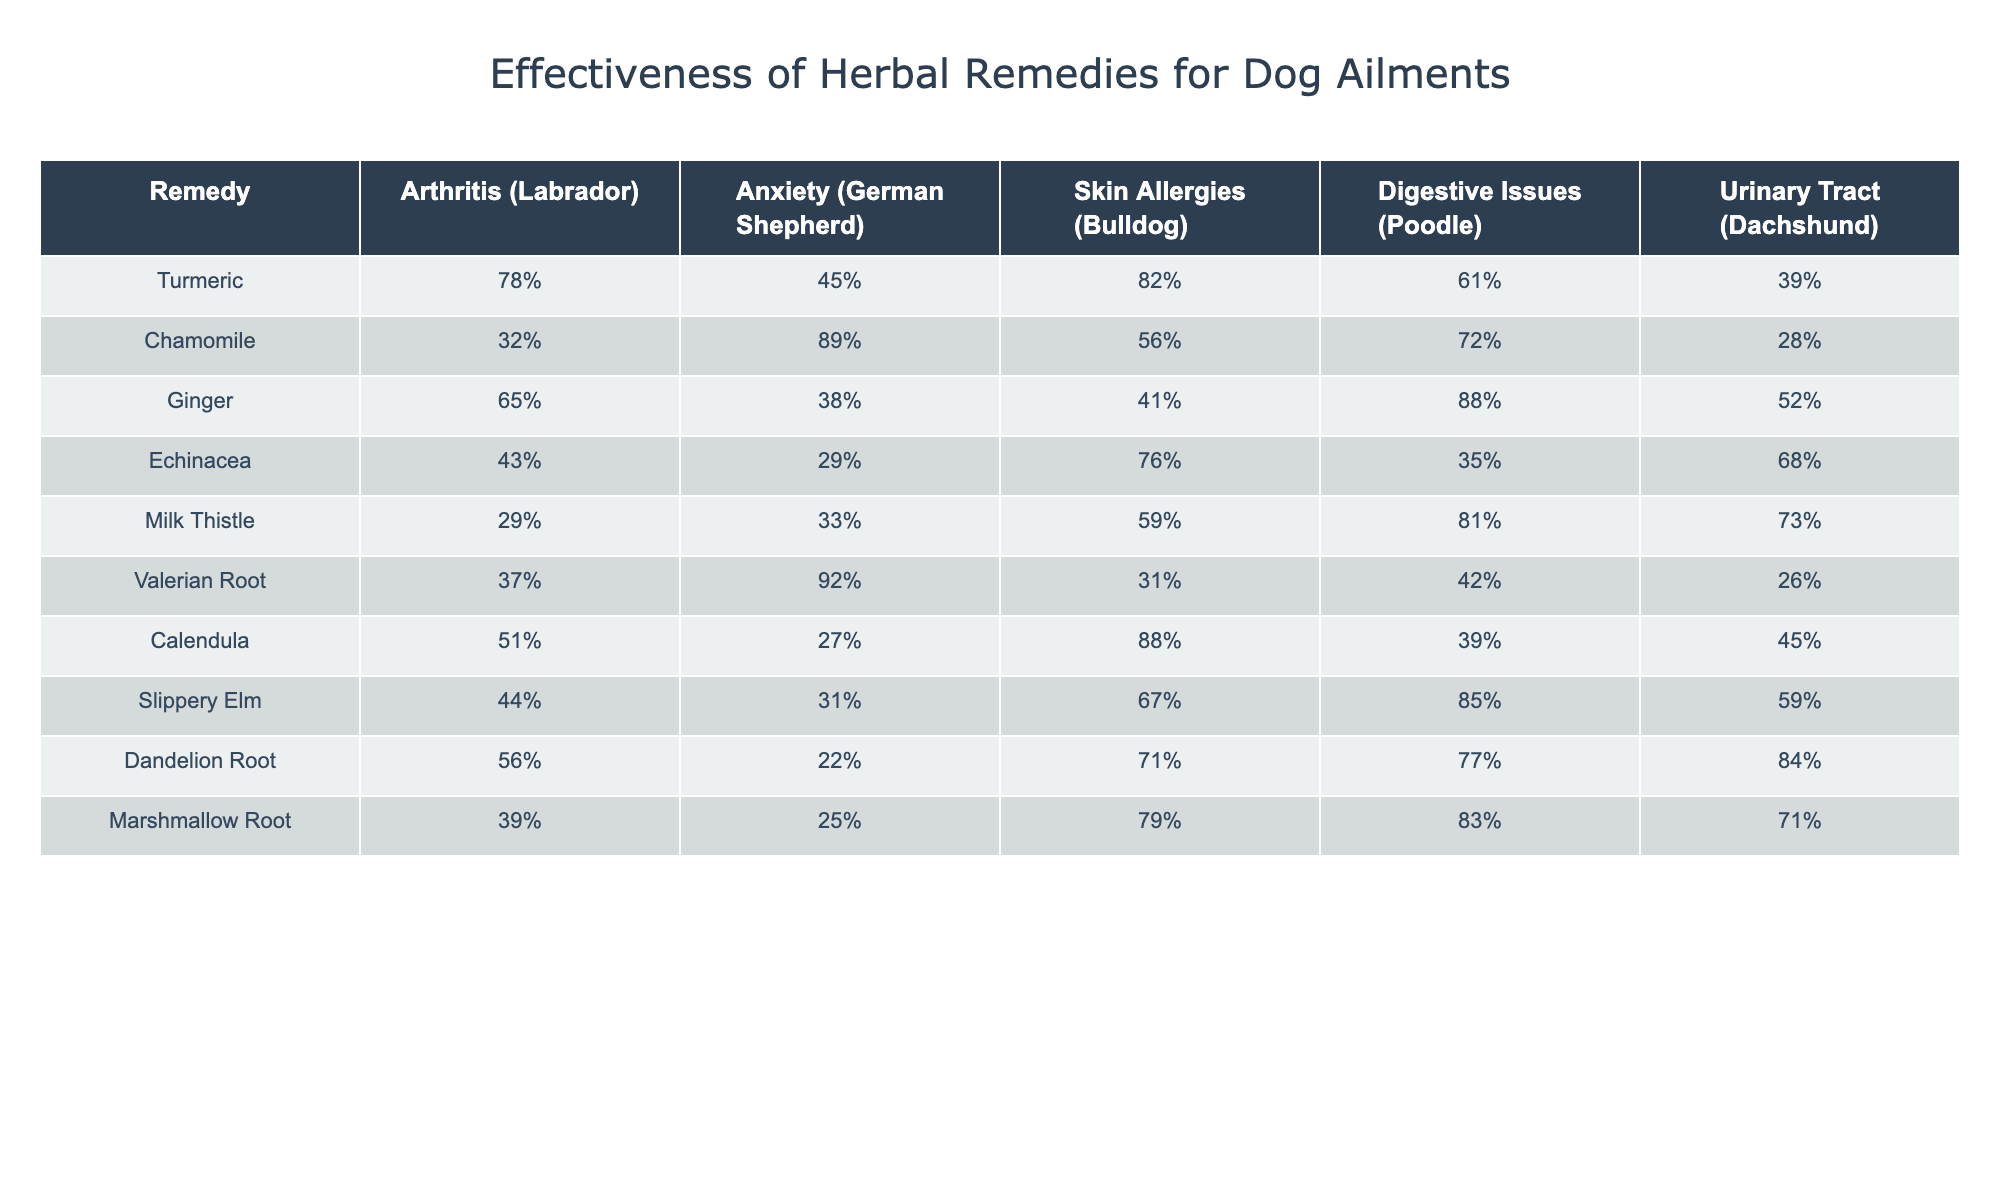What is the effectiveness percentage of Turmeric for Arthritis in Labradors? The table indicates that Turmeric has an effectiveness percentage of 78% for treating Arthritis in Labradors.
Answer: 78% Which herbal remedy is most effective for Anxiety in German Shepherds? The highest percentage for Anxiety in German Shepherds is indicated as 89% for Chamomile, making it the most effective remedy.
Answer: Chamomile What is the average effectiveness of Ginger across all ailments listed? To find the average effectiveness of Ginger, we sum its percentages: (65 + 38 + 41 + 88 + 52) = 284. Since there are 5 examples, the average is 284 / 5 = 56.8%.
Answer: 56.8% Is Calendula effective for treating Digestive Issues in Poodles? Yes, the table indicates that Calendula has an effectiveness of 39% for treating Digestive Issues in Poodles.
Answer: Yes Which remedy has the lowest effectiveness for Urinary Tract issues in Dachshunds? By examining the values for Urinary Tract issues, the lowest value is 26% for Valerian Root, making it the least effective.
Answer: Valerian Root What is the difference in effectiveness between Milk Thistle and Slippery Elm for treating Skin Allergies in Bulldogs? Milk Thistle has an effectiveness percentage of 59% and Slippery Elm has 67%. The difference is 67 - 59 = 8%.
Answer: 8% Which remedy has a higher effectiveness: Dandelion Root for Digestive Issues or Chamomile for Anxiety? Dandelion Root for Digestive Issues is at 77% and Chamomile for Anxiety is 89%. Since 89% > 77%, we conclude Chamomile is more effective.
Answer: Chamomile Are there any remedies that have over 80% effectiveness for Skin Allergies in Bulldogs? Yes, the table shows that both Turmeric (82%) and Calendula (88%) have effectiveness percentages above 80% for Skin Allergies in Bulldogs.
Answer: Yes What is the maximum effectiveness percentage across all remedies for any ailment listed? The highest effectiveness percentage in the table is 89% for Chamomile in treating Anxiety in German Shepherds.
Answer: 89% How does the effectiveness of Echinacea for Digestion compare to that of Ginger? Echinacea's effectiveness for Digestive Issues is 35%, while Ginger's is 88%. Since 88% > 35%, Ginger is more effective for Digestion.
Answer: Ginger 